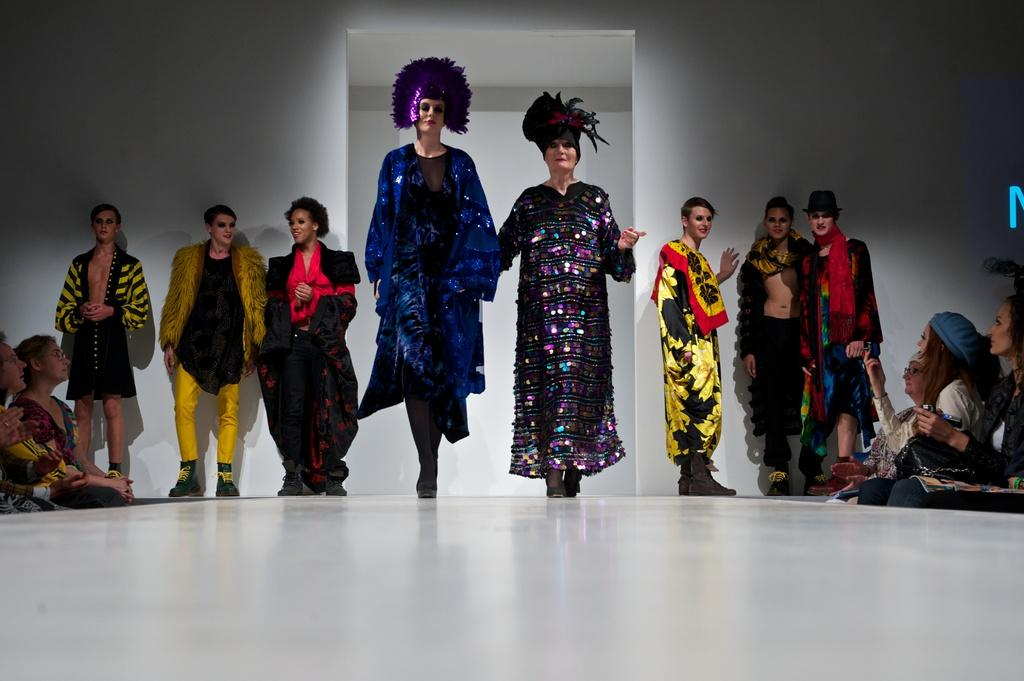How many people are in the image? There are people in the image, but the exact number is not specified. What are the people doing in the image? The people are standing in the image. What are the people wearing in the image? The people are wearing different costumes in the image. What colors can be seen on the costumes? The costumes are in different colors. What is the color of the floor in the image? The floor in the image is white. What is the color of the wall in the image? The wall in the image is white. What type of payment is being made in the image? There is no indication of any payment being made in the image. How many heads are visible in the image? The number of heads visible in the image is not specified, but there are people present. 